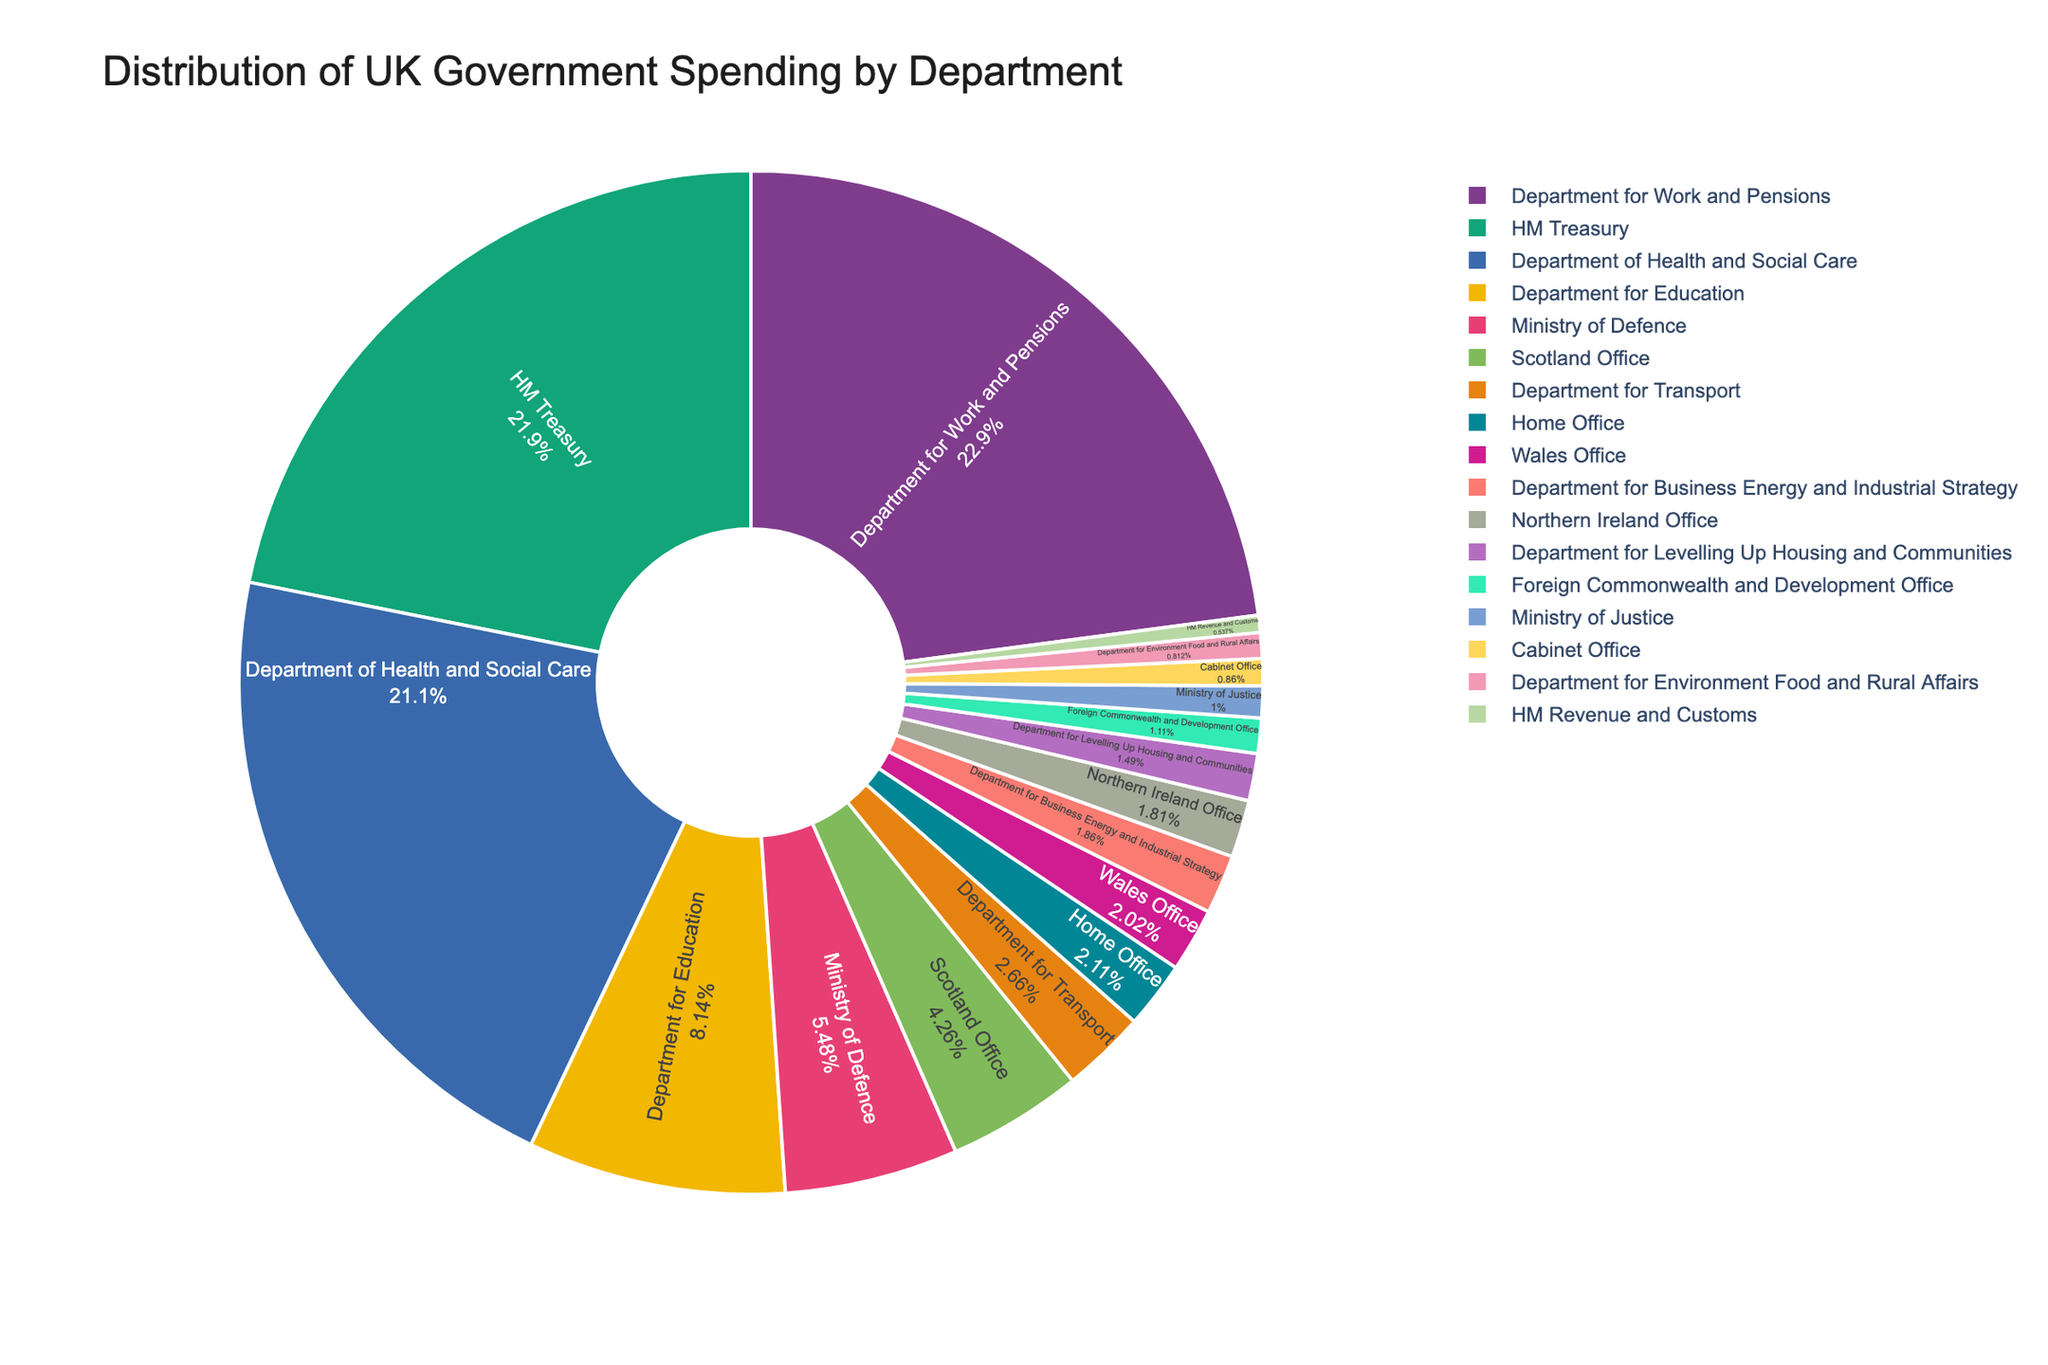What's the largest department in terms of government spending? The largest department is the one with the largest slice in the pie chart.
Answer: Department for Work and Pensions How does the spending of the Department for Work and Pensions compare to the Department of Health and Social Care? Identify the slices corresponding to these two departments and compare their sizes. The Department for Work and Pensions has a larger slice, indicating higher spending.
Answer: Department for Work and Pensions spends more Which departments have nearly equal spending levels? Look for similarly sized slices. The Home Office and Department for Levelling Up Housing and Communities have nearly equal spending levels.
Answer: Home Office and Department for Levelling Up Housing and Communities What percentage of the total spending is allocated to the Department for Education? Find the Department for Education slice and read its percentage label.
Answer: Approximately 10% List the departments with spending above 50 billion GBP. Look for slices representing more than one-tenth of the pie (total of 768.6 billion GBP). Identify the departments: Department for Work and Pensions, Department of Health and Social Care, and HM Treasury.
Answer: Department for Work and Pensions, Department of Health and Social Care, HM Treasury What is the combined spending of the Foreign Commonwealth and Development Office and the Department for Environment Food and Rural Affairs? Add the spending amounts of the two departments: 9.3 + 6.8 = 16.1 billion GBP
Answer: 16.1 billion GBP Which department occupies the smallest slice in the pie chart? Find the smallest slice in the pie chart.
Answer: HM Revenue and Customs How does the number of departments with spending below 20 billion GBP compare to those with spending above 50 billion GBP? Count the departments in each category: below 20 billion GBP (12 departments) and above 50 billion GBP (3 departments).
Answer: More departments below 20 billion GBP What is the difference in spending between the Ministry of Defence and the Wales Office? Subtract the spending of the Wales Office from the Ministry of Defence: 45.9 - 16.9 = 29 billion GBP.
Answer: 29 billion GBP Which departments have spending between 10 and 20 billion GBP? Identify the slices within this range: Home Office, Department for Transport, Department for Business Energy and Industrial Strategy, Department for Levelling Up Housing and Communities, Wales Office, Northern Ireland Office.
Answer: Home Office, Dept for Transport, Dept for Business Energy and Industrial Strategy, Dept for Levelling Up Housing and Communities, Wales Office, Northern Ireland Office 